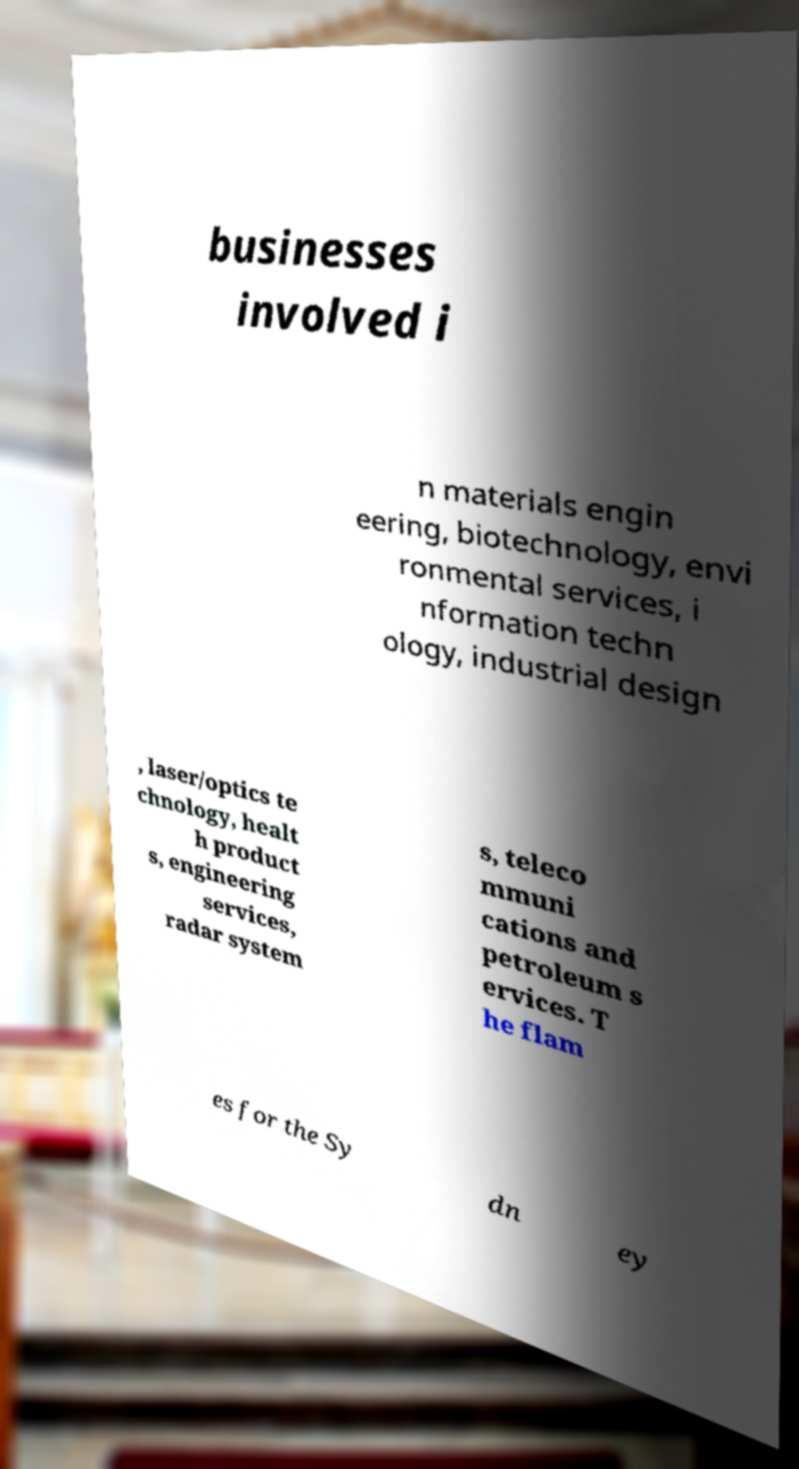Could you extract and type out the text from this image? businesses involved i n materials engin eering, biotechnology, envi ronmental services, i nformation techn ology, industrial design , laser/optics te chnology, healt h product s, engineering services, radar system s, teleco mmuni cations and petroleum s ervices. T he flam es for the Sy dn ey 